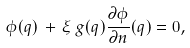Convert formula to latex. <formula><loc_0><loc_0><loc_500><loc_500>\phi ( q ) \, + \, \xi \, g ( q ) \frac { \partial \phi } { \partial { n } } ( q ) = 0 ,</formula> 